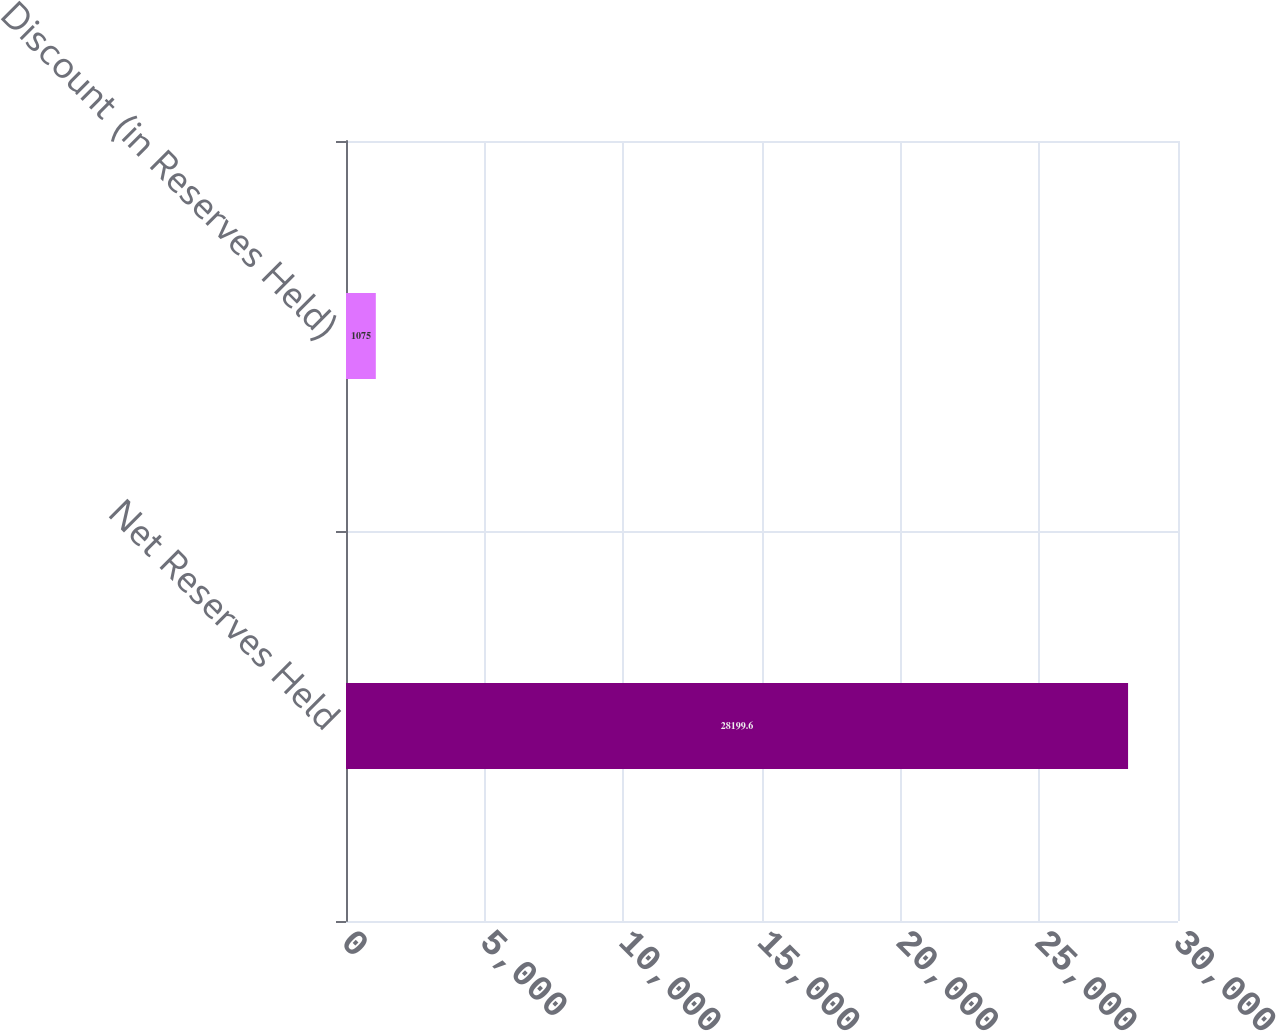<chart> <loc_0><loc_0><loc_500><loc_500><bar_chart><fcel>Net Reserves Held<fcel>Discount (in Reserves Held)<nl><fcel>28199.6<fcel>1075<nl></chart> 